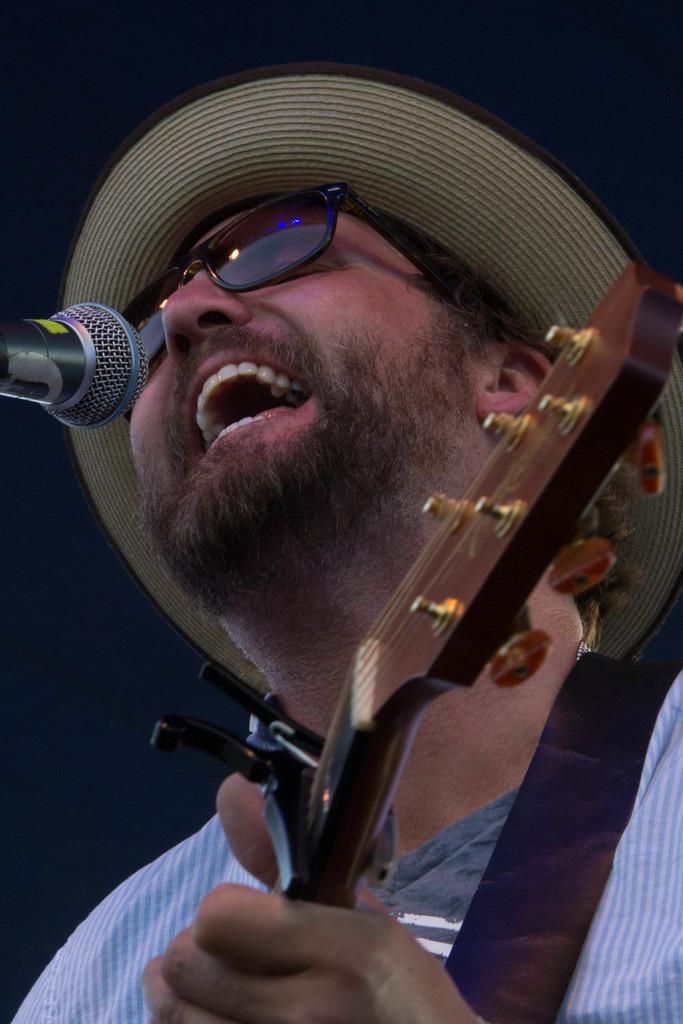What is the main subject of the image? The main subject of the image is a man. What is the man doing in the image? The man is performing in the image. What can be seen near the man in the image? The man is in front of a microphone. What accessories is the man wearing in the image? The man is wearing a hat and spectacles in the image. What is the man holding in his hand in the image? The man is holding a musical instrument in his hand in the image. What type of shirt is the man wearing on his throne in the image? There is no throne present in the image, and the man is not wearing a shirt; he is wearing a hat and spectacles. 